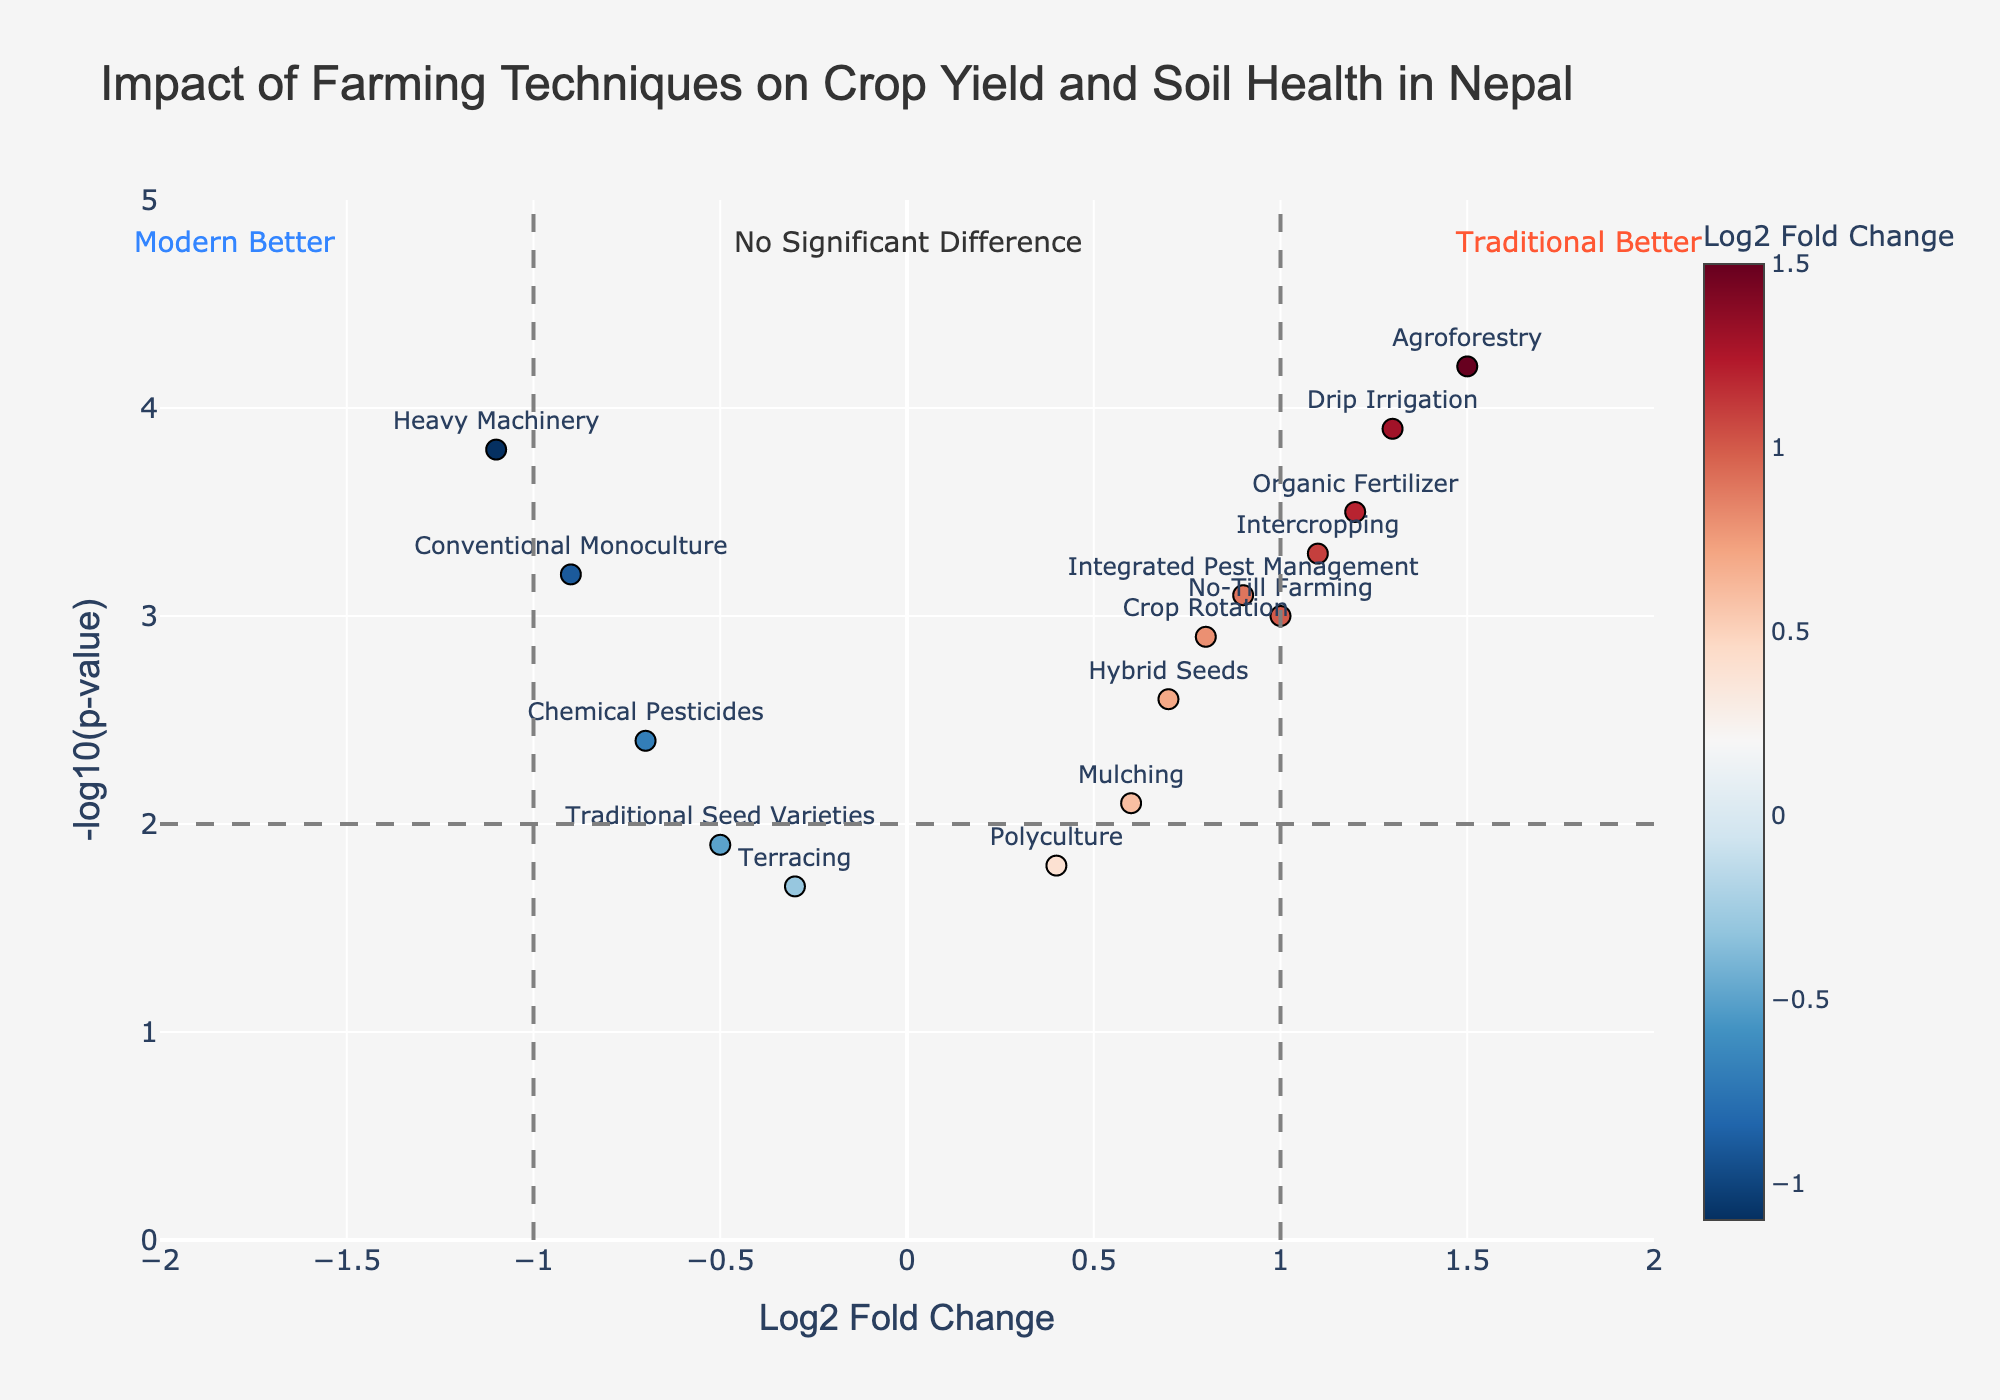What’s the title of the plot? The title is generally located at the top of the plot and provides a summary of what the plot is about. In this case, the title indicates the focus of the analysis.
Answer: Impact of Farming Techniques on Crop Yield and Soil Health in Nepal How many techniques show a positive Log2 Fold Change? To count the techniques with a positive Log2 Fold Change, you should find those data points on the right side of the y-axis (with positive x-values).
Answer: 9 Which farming technique has the highest -log10(p-value)? The highest -log10(p-value) can be identified by the data point that appears at the topmost part of the plot.
Answer: Agroforestry Between Chemical Pesticides and Agroforestry, which technique is better according to the plot? Compare the coordinates of both points. Agroforestry is on the right side with a positive Log2 Fold Change while Chemical Pesticides is on the left with a negative Log2 Fold Change. Additionally, Agroforestry has a higher -log10(p-value).
Answer: Agroforestry Which farming technique placed on the left side of the plot has the most significant p-value? For the left side of the plot (negative Log2 Fold Change), the most significant p-value is the one with the highest -log10(p-value).
Answer: Heavy Machinery What do the vertical lines at x=-1 and x=1 represent? Vertical lines at x=-1 and x=1 typically indicate thresholds beyond which the change is considered significant. On this plot, they divide significant positive changes, significant negative changes, and areas with no significant changes.
Answer: Significance thresholds What can we infer about traditional and modern techniques based on the annotations at the corners of the plot? The annotations indicate that techniques on the left (negative Log2 Fold Change) favor modern methods, while those on the right (positive Log2 Fold Change) favor traditional methods.
Answer: Traditional vs Modern techniques Which data points fall into the “No Significant Difference” category? Data points within the vertical lines at x=-1 and x=1 are considered to show no significant difference in Log2 Fold Change. They are closer to the middle section of the plot.
Answer: Terracing, Crop Rotation, Mulching, Polyculture, Hybrid Seeds 